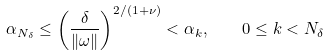<formula> <loc_0><loc_0><loc_500><loc_500>\alpha _ { N _ { \delta } } \leq \left ( \frac { \delta } { \| \omega \| } \right ) ^ { 2 / ( 1 + \nu ) } < \alpha _ { k } , \quad 0 \leq k < N _ { \delta }</formula> 